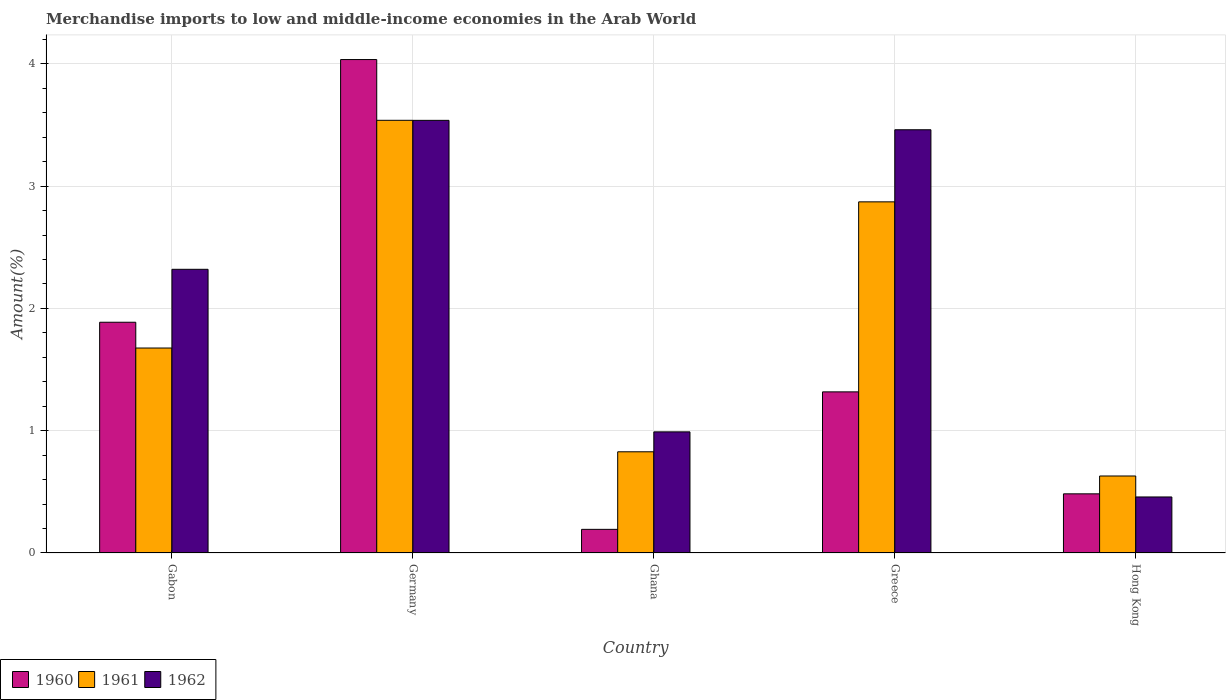How many different coloured bars are there?
Offer a very short reply. 3. Are the number of bars per tick equal to the number of legend labels?
Give a very brief answer. Yes. How many bars are there on the 5th tick from the right?
Provide a succinct answer. 3. What is the label of the 1st group of bars from the left?
Ensure brevity in your answer.  Gabon. In how many cases, is the number of bars for a given country not equal to the number of legend labels?
Provide a short and direct response. 0. What is the percentage of amount earned from merchandise imports in 1961 in Germany?
Provide a succinct answer. 3.54. Across all countries, what is the maximum percentage of amount earned from merchandise imports in 1961?
Your response must be concise. 3.54. Across all countries, what is the minimum percentage of amount earned from merchandise imports in 1962?
Make the answer very short. 0.46. In which country was the percentage of amount earned from merchandise imports in 1960 maximum?
Provide a succinct answer. Germany. In which country was the percentage of amount earned from merchandise imports in 1960 minimum?
Offer a terse response. Ghana. What is the total percentage of amount earned from merchandise imports in 1961 in the graph?
Your answer should be very brief. 9.54. What is the difference between the percentage of amount earned from merchandise imports in 1960 in Gabon and that in Hong Kong?
Offer a terse response. 1.4. What is the difference between the percentage of amount earned from merchandise imports in 1962 in Greece and the percentage of amount earned from merchandise imports in 1960 in Gabon?
Offer a very short reply. 1.57. What is the average percentage of amount earned from merchandise imports in 1960 per country?
Provide a short and direct response. 1.58. What is the difference between the percentage of amount earned from merchandise imports of/in 1962 and percentage of amount earned from merchandise imports of/in 1961 in Greece?
Make the answer very short. 0.59. In how many countries, is the percentage of amount earned from merchandise imports in 1961 greater than 2 %?
Keep it short and to the point. 2. What is the ratio of the percentage of amount earned from merchandise imports in 1960 in Greece to that in Hong Kong?
Provide a succinct answer. 2.72. What is the difference between the highest and the second highest percentage of amount earned from merchandise imports in 1961?
Provide a short and direct response. -1.2. What is the difference between the highest and the lowest percentage of amount earned from merchandise imports in 1961?
Keep it short and to the point. 2.91. What does the 1st bar from the left in Hong Kong represents?
Keep it short and to the point. 1960. How many countries are there in the graph?
Provide a short and direct response. 5. What is the difference between two consecutive major ticks on the Y-axis?
Your answer should be very brief. 1. Are the values on the major ticks of Y-axis written in scientific E-notation?
Provide a succinct answer. No. Does the graph contain any zero values?
Your answer should be very brief. No. Where does the legend appear in the graph?
Provide a short and direct response. Bottom left. How many legend labels are there?
Your answer should be very brief. 3. How are the legend labels stacked?
Offer a very short reply. Horizontal. What is the title of the graph?
Provide a succinct answer. Merchandise imports to low and middle-income economies in the Arab World. Does "1990" appear as one of the legend labels in the graph?
Your answer should be very brief. No. What is the label or title of the X-axis?
Offer a terse response. Country. What is the label or title of the Y-axis?
Make the answer very short. Amount(%). What is the Amount(%) of 1960 in Gabon?
Make the answer very short. 1.89. What is the Amount(%) of 1961 in Gabon?
Offer a very short reply. 1.68. What is the Amount(%) in 1962 in Gabon?
Make the answer very short. 2.32. What is the Amount(%) in 1960 in Germany?
Your response must be concise. 4.03. What is the Amount(%) in 1961 in Germany?
Provide a succinct answer. 3.54. What is the Amount(%) in 1962 in Germany?
Your response must be concise. 3.54. What is the Amount(%) in 1960 in Ghana?
Give a very brief answer. 0.19. What is the Amount(%) in 1961 in Ghana?
Your answer should be very brief. 0.83. What is the Amount(%) of 1962 in Ghana?
Your response must be concise. 0.99. What is the Amount(%) of 1960 in Greece?
Your answer should be compact. 1.32. What is the Amount(%) of 1961 in Greece?
Your answer should be very brief. 2.87. What is the Amount(%) in 1962 in Greece?
Provide a succinct answer. 3.46. What is the Amount(%) of 1960 in Hong Kong?
Your response must be concise. 0.48. What is the Amount(%) in 1961 in Hong Kong?
Your answer should be very brief. 0.63. What is the Amount(%) of 1962 in Hong Kong?
Provide a succinct answer. 0.46. Across all countries, what is the maximum Amount(%) in 1960?
Provide a short and direct response. 4.03. Across all countries, what is the maximum Amount(%) of 1961?
Make the answer very short. 3.54. Across all countries, what is the maximum Amount(%) in 1962?
Offer a very short reply. 3.54. Across all countries, what is the minimum Amount(%) in 1960?
Make the answer very short. 0.19. Across all countries, what is the minimum Amount(%) in 1961?
Give a very brief answer. 0.63. Across all countries, what is the minimum Amount(%) of 1962?
Offer a terse response. 0.46. What is the total Amount(%) in 1960 in the graph?
Provide a short and direct response. 7.92. What is the total Amount(%) of 1961 in the graph?
Offer a terse response. 9.54. What is the total Amount(%) of 1962 in the graph?
Offer a very short reply. 10.77. What is the difference between the Amount(%) of 1960 in Gabon and that in Germany?
Your answer should be very brief. -2.15. What is the difference between the Amount(%) in 1961 in Gabon and that in Germany?
Ensure brevity in your answer.  -1.86. What is the difference between the Amount(%) of 1962 in Gabon and that in Germany?
Make the answer very short. -1.22. What is the difference between the Amount(%) of 1960 in Gabon and that in Ghana?
Your answer should be compact. 1.69. What is the difference between the Amount(%) in 1961 in Gabon and that in Ghana?
Keep it short and to the point. 0.85. What is the difference between the Amount(%) in 1962 in Gabon and that in Ghana?
Make the answer very short. 1.33. What is the difference between the Amount(%) of 1960 in Gabon and that in Greece?
Offer a very short reply. 0.57. What is the difference between the Amount(%) of 1961 in Gabon and that in Greece?
Provide a succinct answer. -1.2. What is the difference between the Amount(%) in 1962 in Gabon and that in Greece?
Your answer should be very brief. -1.14. What is the difference between the Amount(%) of 1960 in Gabon and that in Hong Kong?
Your answer should be very brief. 1.4. What is the difference between the Amount(%) of 1961 in Gabon and that in Hong Kong?
Offer a terse response. 1.05. What is the difference between the Amount(%) of 1962 in Gabon and that in Hong Kong?
Give a very brief answer. 1.86. What is the difference between the Amount(%) in 1960 in Germany and that in Ghana?
Provide a short and direct response. 3.84. What is the difference between the Amount(%) of 1961 in Germany and that in Ghana?
Offer a terse response. 2.71. What is the difference between the Amount(%) in 1962 in Germany and that in Ghana?
Ensure brevity in your answer.  2.55. What is the difference between the Amount(%) in 1960 in Germany and that in Greece?
Your answer should be very brief. 2.72. What is the difference between the Amount(%) of 1961 in Germany and that in Greece?
Give a very brief answer. 0.67. What is the difference between the Amount(%) of 1962 in Germany and that in Greece?
Provide a short and direct response. 0.08. What is the difference between the Amount(%) in 1960 in Germany and that in Hong Kong?
Make the answer very short. 3.55. What is the difference between the Amount(%) in 1961 in Germany and that in Hong Kong?
Ensure brevity in your answer.  2.91. What is the difference between the Amount(%) in 1962 in Germany and that in Hong Kong?
Make the answer very short. 3.08. What is the difference between the Amount(%) of 1960 in Ghana and that in Greece?
Keep it short and to the point. -1.12. What is the difference between the Amount(%) of 1961 in Ghana and that in Greece?
Provide a succinct answer. -2.04. What is the difference between the Amount(%) of 1962 in Ghana and that in Greece?
Provide a short and direct response. -2.47. What is the difference between the Amount(%) of 1960 in Ghana and that in Hong Kong?
Ensure brevity in your answer.  -0.29. What is the difference between the Amount(%) in 1961 in Ghana and that in Hong Kong?
Ensure brevity in your answer.  0.2. What is the difference between the Amount(%) in 1962 in Ghana and that in Hong Kong?
Ensure brevity in your answer.  0.53. What is the difference between the Amount(%) of 1960 in Greece and that in Hong Kong?
Provide a succinct answer. 0.83. What is the difference between the Amount(%) in 1961 in Greece and that in Hong Kong?
Keep it short and to the point. 2.24. What is the difference between the Amount(%) in 1962 in Greece and that in Hong Kong?
Your answer should be compact. 3. What is the difference between the Amount(%) in 1960 in Gabon and the Amount(%) in 1961 in Germany?
Provide a succinct answer. -1.65. What is the difference between the Amount(%) in 1960 in Gabon and the Amount(%) in 1962 in Germany?
Your answer should be compact. -1.65. What is the difference between the Amount(%) of 1961 in Gabon and the Amount(%) of 1962 in Germany?
Provide a short and direct response. -1.86. What is the difference between the Amount(%) of 1960 in Gabon and the Amount(%) of 1961 in Ghana?
Your response must be concise. 1.06. What is the difference between the Amount(%) in 1960 in Gabon and the Amount(%) in 1962 in Ghana?
Ensure brevity in your answer.  0.9. What is the difference between the Amount(%) in 1961 in Gabon and the Amount(%) in 1962 in Ghana?
Offer a very short reply. 0.69. What is the difference between the Amount(%) in 1960 in Gabon and the Amount(%) in 1961 in Greece?
Offer a very short reply. -0.98. What is the difference between the Amount(%) of 1960 in Gabon and the Amount(%) of 1962 in Greece?
Provide a short and direct response. -1.57. What is the difference between the Amount(%) in 1961 in Gabon and the Amount(%) in 1962 in Greece?
Offer a very short reply. -1.78. What is the difference between the Amount(%) of 1960 in Gabon and the Amount(%) of 1961 in Hong Kong?
Make the answer very short. 1.26. What is the difference between the Amount(%) of 1960 in Gabon and the Amount(%) of 1962 in Hong Kong?
Provide a short and direct response. 1.43. What is the difference between the Amount(%) of 1961 in Gabon and the Amount(%) of 1962 in Hong Kong?
Your response must be concise. 1.22. What is the difference between the Amount(%) of 1960 in Germany and the Amount(%) of 1961 in Ghana?
Provide a short and direct response. 3.21. What is the difference between the Amount(%) of 1960 in Germany and the Amount(%) of 1962 in Ghana?
Give a very brief answer. 3.04. What is the difference between the Amount(%) of 1961 in Germany and the Amount(%) of 1962 in Ghana?
Provide a succinct answer. 2.55. What is the difference between the Amount(%) in 1960 in Germany and the Amount(%) in 1961 in Greece?
Ensure brevity in your answer.  1.16. What is the difference between the Amount(%) of 1960 in Germany and the Amount(%) of 1962 in Greece?
Your answer should be compact. 0.57. What is the difference between the Amount(%) in 1961 in Germany and the Amount(%) in 1962 in Greece?
Provide a short and direct response. 0.08. What is the difference between the Amount(%) of 1960 in Germany and the Amount(%) of 1961 in Hong Kong?
Offer a very short reply. 3.41. What is the difference between the Amount(%) in 1960 in Germany and the Amount(%) in 1962 in Hong Kong?
Provide a short and direct response. 3.58. What is the difference between the Amount(%) in 1961 in Germany and the Amount(%) in 1962 in Hong Kong?
Give a very brief answer. 3.08. What is the difference between the Amount(%) in 1960 in Ghana and the Amount(%) in 1961 in Greece?
Your response must be concise. -2.68. What is the difference between the Amount(%) in 1960 in Ghana and the Amount(%) in 1962 in Greece?
Your answer should be compact. -3.27. What is the difference between the Amount(%) in 1961 in Ghana and the Amount(%) in 1962 in Greece?
Your answer should be compact. -2.63. What is the difference between the Amount(%) of 1960 in Ghana and the Amount(%) of 1961 in Hong Kong?
Your answer should be very brief. -0.44. What is the difference between the Amount(%) in 1960 in Ghana and the Amount(%) in 1962 in Hong Kong?
Provide a succinct answer. -0.26. What is the difference between the Amount(%) of 1961 in Ghana and the Amount(%) of 1962 in Hong Kong?
Your response must be concise. 0.37. What is the difference between the Amount(%) in 1960 in Greece and the Amount(%) in 1961 in Hong Kong?
Offer a terse response. 0.69. What is the difference between the Amount(%) in 1960 in Greece and the Amount(%) in 1962 in Hong Kong?
Keep it short and to the point. 0.86. What is the difference between the Amount(%) of 1961 in Greece and the Amount(%) of 1962 in Hong Kong?
Make the answer very short. 2.41. What is the average Amount(%) in 1960 per country?
Provide a succinct answer. 1.58. What is the average Amount(%) of 1961 per country?
Make the answer very short. 1.91. What is the average Amount(%) in 1962 per country?
Provide a succinct answer. 2.15. What is the difference between the Amount(%) in 1960 and Amount(%) in 1961 in Gabon?
Provide a succinct answer. 0.21. What is the difference between the Amount(%) in 1960 and Amount(%) in 1962 in Gabon?
Keep it short and to the point. -0.43. What is the difference between the Amount(%) in 1961 and Amount(%) in 1962 in Gabon?
Your answer should be very brief. -0.64. What is the difference between the Amount(%) in 1960 and Amount(%) in 1961 in Germany?
Make the answer very short. 0.5. What is the difference between the Amount(%) in 1960 and Amount(%) in 1962 in Germany?
Ensure brevity in your answer.  0.5. What is the difference between the Amount(%) of 1960 and Amount(%) of 1961 in Ghana?
Offer a very short reply. -0.63. What is the difference between the Amount(%) of 1960 and Amount(%) of 1962 in Ghana?
Provide a short and direct response. -0.8. What is the difference between the Amount(%) of 1961 and Amount(%) of 1962 in Ghana?
Your answer should be very brief. -0.16. What is the difference between the Amount(%) in 1960 and Amount(%) in 1961 in Greece?
Offer a terse response. -1.55. What is the difference between the Amount(%) in 1960 and Amount(%) in 1962 in Greece?
Offer a terse response. -2.14. What is the difference between the Amount(%) in 1961 and Amount(%) in 1962 in Greece?
Your response must be concise. -0.59. What is the difference between the Amount(%) of 1960 and Amount(%) of 1961 in Hong Kong?
Provide a short and direct response. -0.15. What is the difference between the Amount(%) in 1960 and Amount(%) in 1962 in Hong Kong?
Offer a very short reply. 0.03. What is the difference between the Amount(%) in 1961 and Amount(%) in 1962 in Hong Kong?
Offer a terse response. 0.17. What is the ratio of the Amount(%) in 1960 in Gabon to that in Germany?
Keep it short and to the point. 0.47. What is the ratio of the Amount(%) of 1961 in Gabon to that in Germany?
Ensure brevity in your answer.  0.47. What is the ratio of the Amount(%) of 1962 in Gabon to that in Germany?
Your answer should be compact. 0.66. What is the ratio of the Amount(%) of 1960 in Gabon to that in Ghana?
Provide a succinct answer. 9.76. What is the ratio of the Amount(%) in 1961 in Gabon to that in Ghana?
Keep it short and to the point. 2.03. What is the ratio of the Amount(%) in 1962 in Gabon to that in Ghana?
Give a very brief answer. 2.34. What is the ratio of the Amount(%) in 1960 in Gabon to that in Greece?
Your answer should be compact. 1.43. What is the ratio of the Amount(%) of 1961 in Gabon to that in Greece?
Keep it short and to the point. 0.58. What is the ratio of the Amount(%) of 1962 in Gabon to that in Greece?
Offer a very short reply. 0.67. What is the ratio of the Amount(%) of 1960 in Gabon to that in Hong Kong?
Give a very brief answer. 3.9. What is the ratio of the Amount(%) of 1961 in Gabon to that in Hong Kong?
Offer a terse response. 2.66. What is the ratio of the Amount(%) in 1962 in Gabon to that in Hong Kong?
Your answer should be very brief. 5.06. What is the ratio of the Amount(%) of 1960 in Germany to that in Ghana?
Provide a short and direct response. 20.87. What is the ratio of the Amount(%) in 1961 in Germany to that in Ghana?
Your answer should be compact. 4.28. What is the ratio of the Amount(%) in 1962 in Germany to that in Ghana?
Your answer should be very brief. 3.57. What is the ratio of the Amount(%) in 1960 in Germany to that in Greece?
Give a very brief answer. 3.06. What is the ratio of the Amount(%) of 1961 in Germany to that in Greece?
Your answer should be compact. 1.23. What is the ratio of the Amount(%) in 1962 in Germany to that in Greece?
Keep it short and to the point. 1.02. What is the ratio of the Amount(%) of 1960 in Germany to that in Hong Kong?
Your response must be concise. 8.34. What is the ratio of the Amount(%) of 1961 in Germany to that in Hong Kong?
Keep it short and to the point. 5.62. What is the ratio of the Amount(%) of 1962 in Germany to that in Hong Kong?
Provide a succinct answer. 7.72. What is the ratio of the Amount(%) of 1960 in Ghana to that in Greece?
Offer a very short reply. 0.15. What is the ratio of the Amount(%) in 1961 in Ghana to that in Greece?
Your answer should be very brief. 0.29. What is the ratio of the Amount(%) of 1962 in Ghana to that in Greece?
Provide a short and direct response. 0.29. What is the ratio of the Amount(%) in 1960 in Ghana to that in Hong Kong?
Provide a short and direct response. 0.4. What is the ratio of the Amount(%) of 1961 in Ghana to that in Hong Kong?
Your answer should be very brief. 1.31. What is the ratio of the Amount(%) in 1962 in Ghana to that in Hong Kong?
Make the answer very short. 2.16. What is the ratio of the Amount(%) of 1960 in Greece to that in Hong Kong?
Provide a succinct answer. 2.72. What is the ratio of the Amount(%) of 1961 in Greece to that in Hong Kong?
Offer a very short reply. 4.56. What is the ratio of the Amount(%) of 1962 in Greece to that in Hong Kong?
Keep it short and to the point. 7.55. What is the difference between the highest and the second highest Amount(%) of 1960?
Keep it short and to the point. 2.15. What is the difference between the highest and the second highest Amount(%) of 1962?
Your answer should be very brief. 0.08. What is the difference between the highest and the lowest Amount(%) in 1960?
Provide a short and direct response. 3.84. What is the difference between the highest and the lowest Amount(%) in 1961?
Ensure brevity in your answer.  2.91. What is the difference between the highest and the lowest Amount(%) of 1962?
Offer a very short reply. 3.08. 